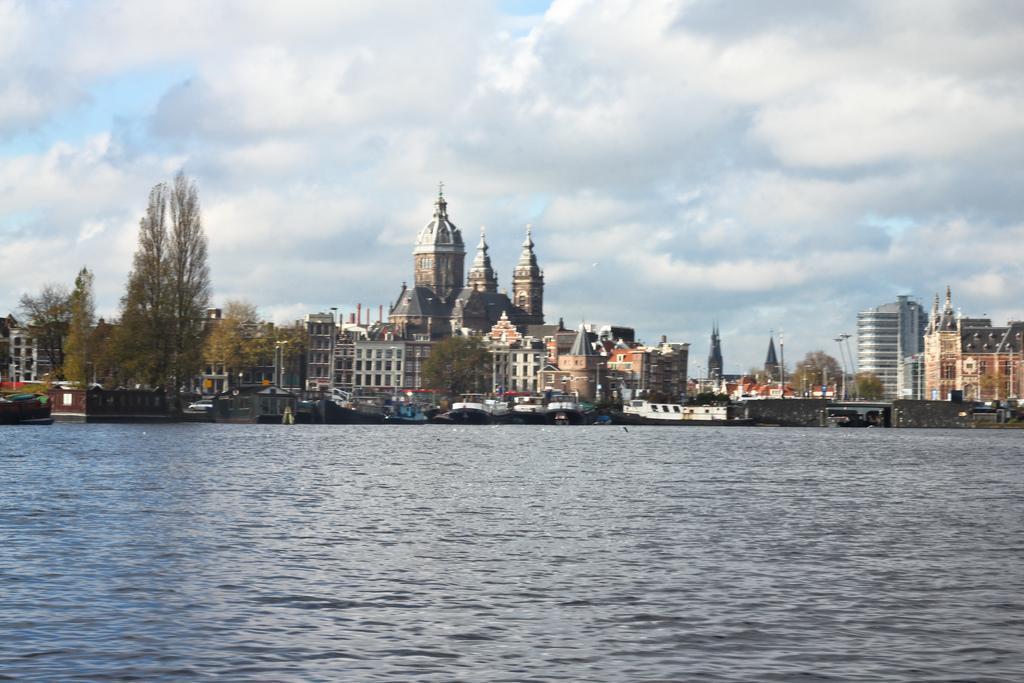How would you summarize this image in a sentence or two? This picture shows few buildings and we see trees and few boats in the water and we see a blue cloudy sky. 